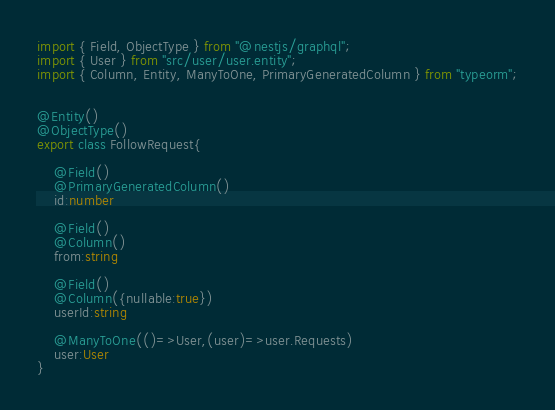<code> <loc_0><loc_0><loc_500><loc_500><_TypeScript_>import { Field, ObjectType } from "@nestjs/graphql";
import { User } from "src/user/user.entity";
import { Column, Entity, ManyToOne, PrimaryGeneratedColumn } from "typeorm";


@Entity()
@ObjectType()
export class FollowRequest{
    
    @Field()
    @PrimaryGeneratedColumn()
    id:number

    @Field()
    @Column()
    from:string

    @Field()
    @Column({nullable:true})
    userId:string

    @ManyToOne(()=>User,(user)=>user.Requests)
    user:User
}</code> 